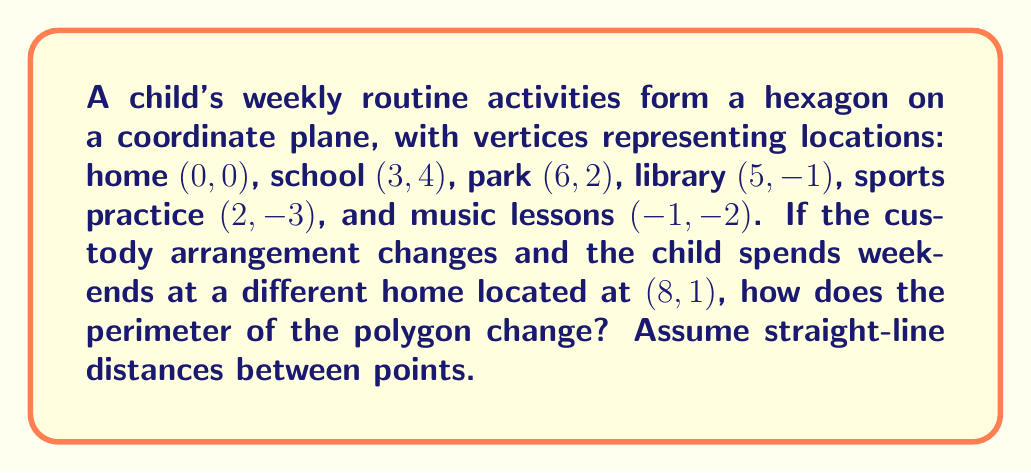Help me with this question. 1. Calculate the original perimeter:
   a) Distance between points using the distance formula: 
      $d = \sqrt{(x_2-x_1)^2 + (y_2-y_1)^2}$
   b) Calculate each side:
      home to school: $\sqrt{3^2 + 4^2} = 5$
      school to park: $\sqrt{3^2 + (-2)^2} = \sqrt{13}$
      park to library: $\sqrt{(-1)^2 + (-3)^2} = \sqrt{10}$
      library to sports: $\sqrt{(-3)^2 + (-2)^2} = \sqrt{13}$
      sports to music: $\sqrt{(-3)^2 + 1^2} = \sqrt{10}$
      music to home: $\sqrt{1^2 + 2^2} = \sqrt{5}$
   c) Sum all sides: $5 + \sqrt{13} + \sqrt{10} + \sqrt{13} + \sqrt{10} + \sqrt{5} \approx 17.07$

2. Calculate the new perimeter:
   a) Replace "home to school" and "music to home" with:
      weekend home to school: $\sqrt{5^2 + 3^2} = \sqrt{34}$
      music to weekend home: $\sqrt{9^2 + 3^2} = \sqrt{90}$
   b) New sum: $\sqrt{34} + \sqrt{13} + \sqrt{10} + \sqrt{13} + \sqrt{10} + \sqrt{90} \approx 23.24$

3. Calculate the difference:
   $23.24 - 17.07 = 6.17$

The perimeter increases by approximately 6.17 units.
Answer: The perimeter increases by 6.17 units. 